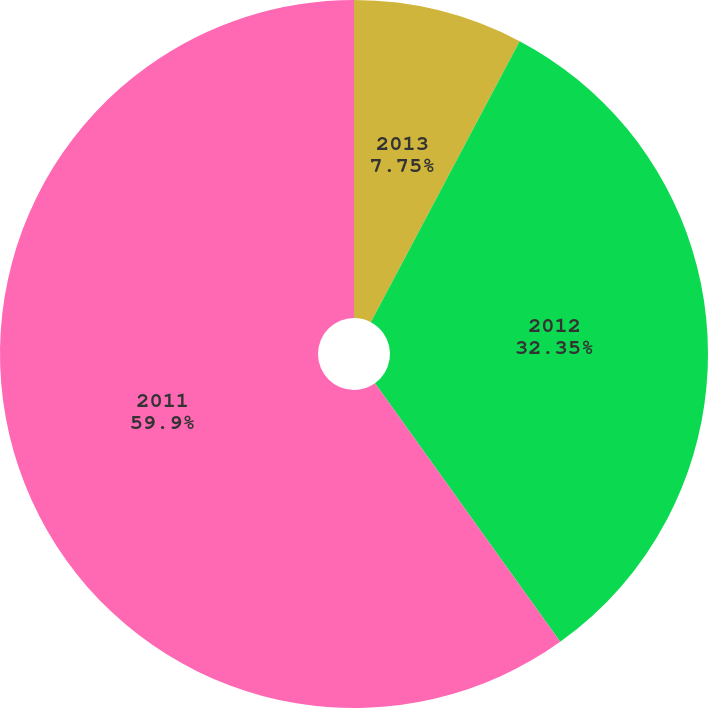Convert chart. <chart><loc_0><loc_0><loc_500><loc_500><pie_chart><fcel>2013<fcel>2012<fcel>2011<nl><fcel>7.75%<fcel>32.35%<fcel>59.89%<nl></chart> 